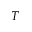<formula> <loc_0><loc_0><loc_500><loc_500>T</formula> 